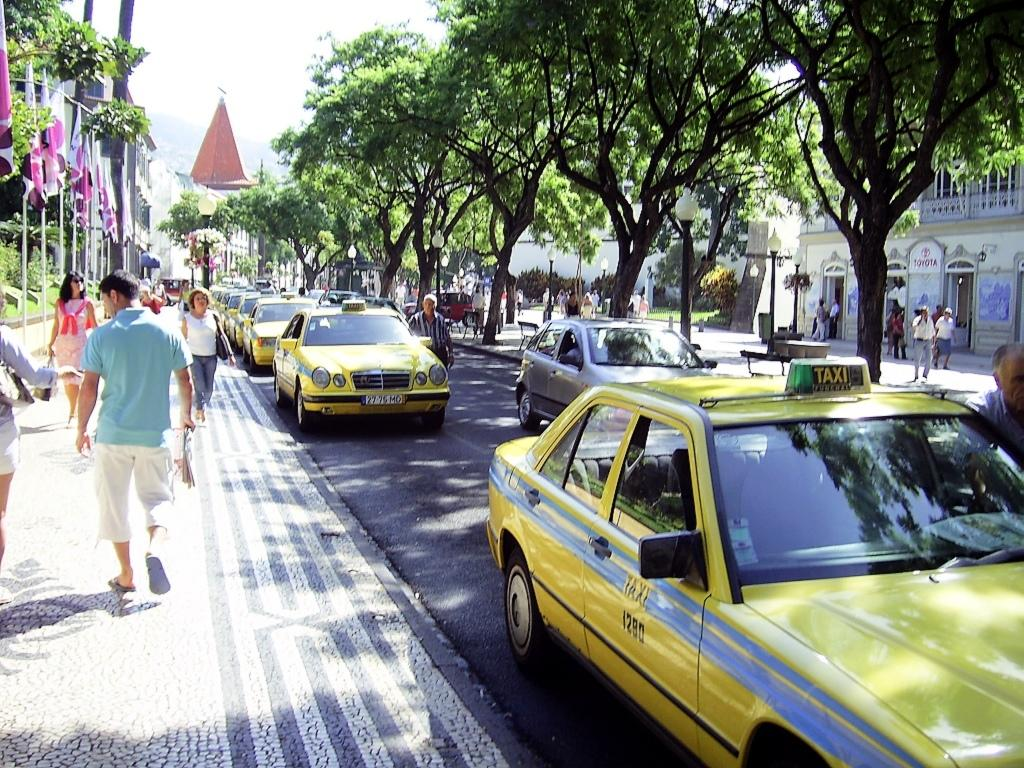<image>
Offer a succinct explanation of the picture presented. People are walking down a sidewalk and yellow cars that say Taxi on top are going down the street. 